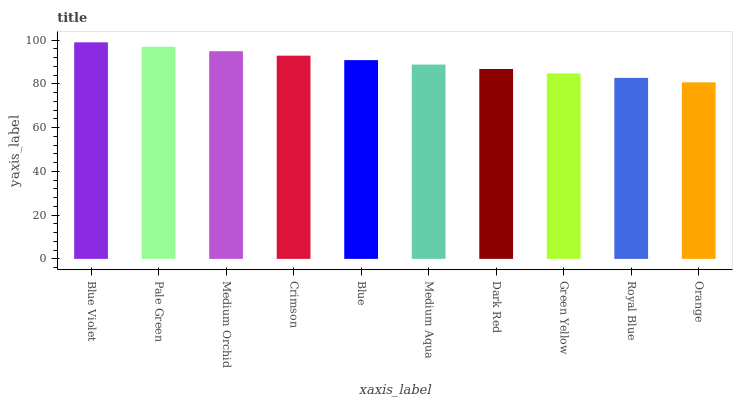Is Orange the minimum?
Answer yes or no. Yes. Is Blue Violet the maximum?
Answer yes or no. Yes. Is Pale Green the minimum?
Answer yes or no. No. Is Pale Green the maximum?
Answer yes or no. No. Is Blue Violet greater than Pale Green?
Answer yes or no. Yes. Is Pale Green less than Blue Violet?
Answer yes or no. Yes. Is Pale Green greater than Blue Violet?
Answer yes or no. No. Is Blue Violet less than Pale Green?
Answer yes or no. No. Is Blue the high median?
Answer yes or no. Yes. Is Medium Aqua the low median?
Answer yes or no. Yes. Is Green Yellow the high median?
Answer yes or no. No. Is Pale Green the low median?
Answer yes or no. No. 